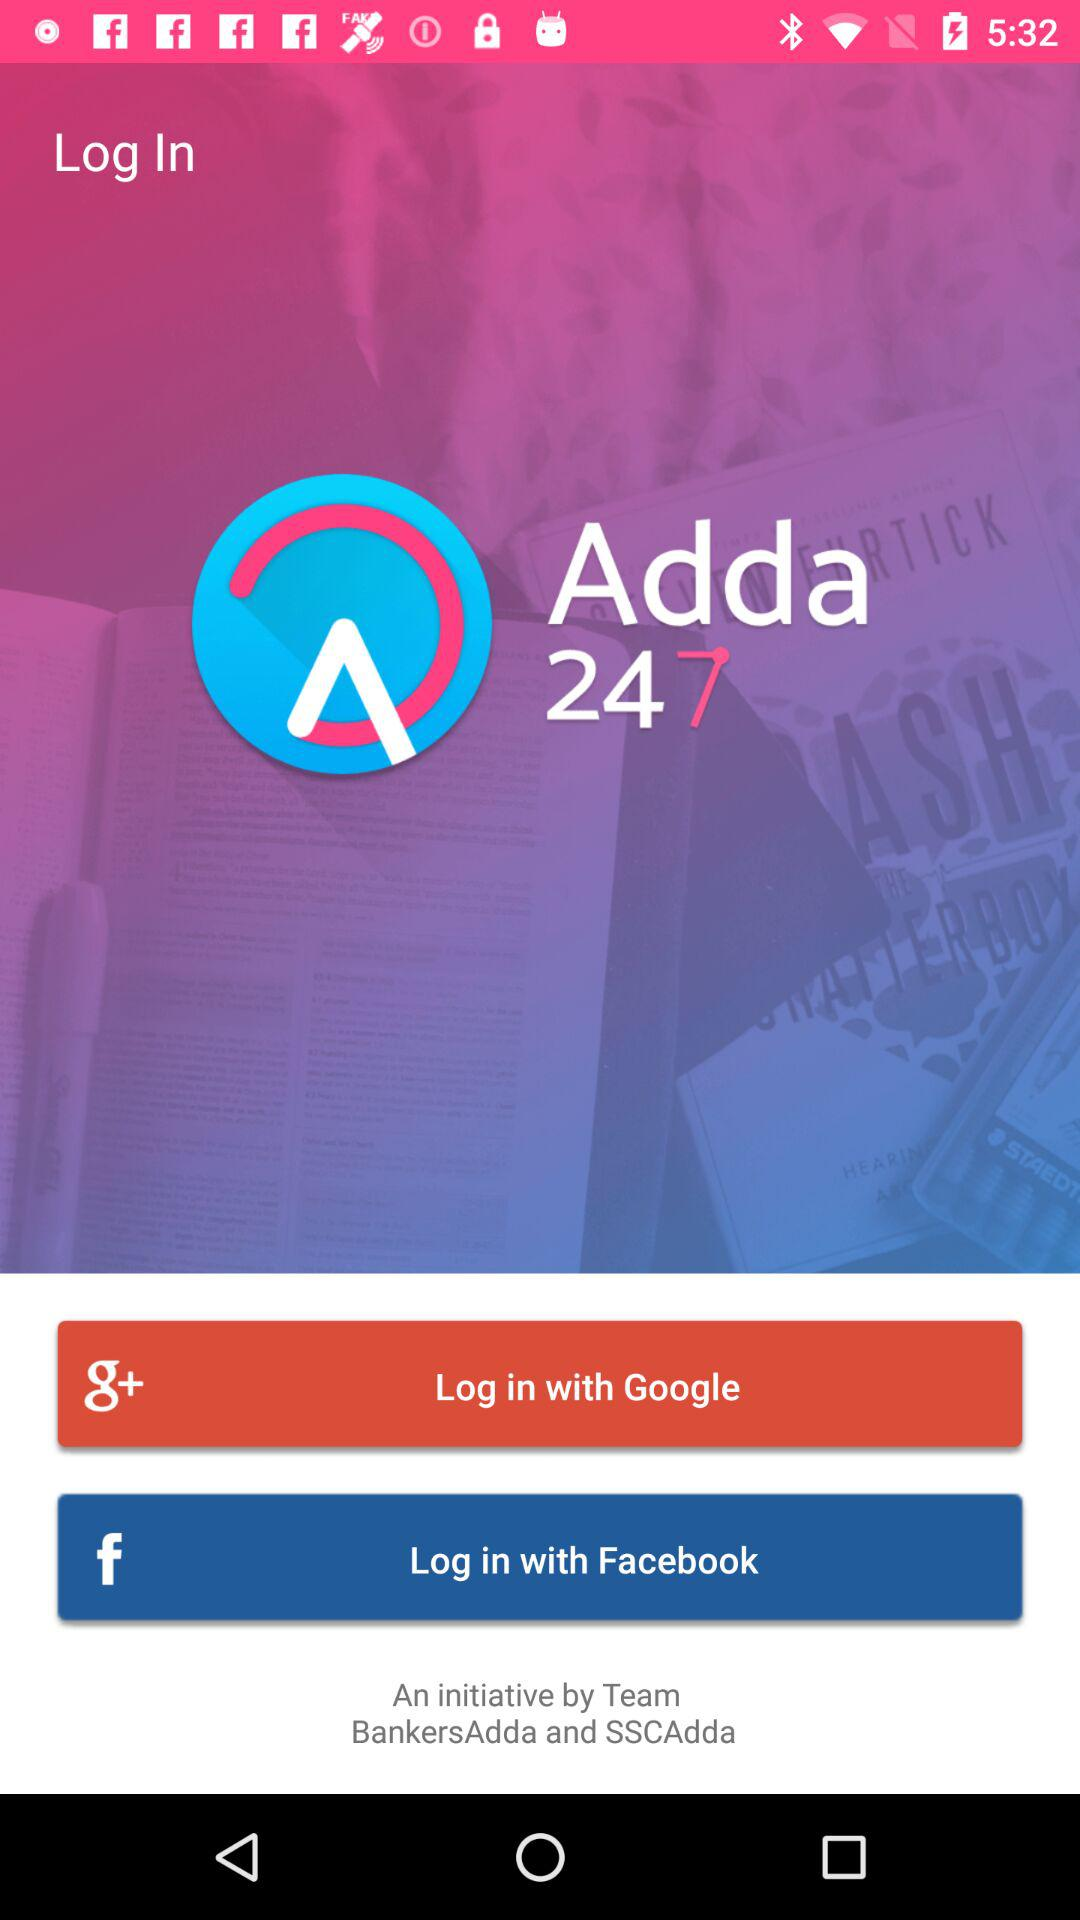Which applications can we use to log in? You can use "Google" and "Facebook" applications to log in. 